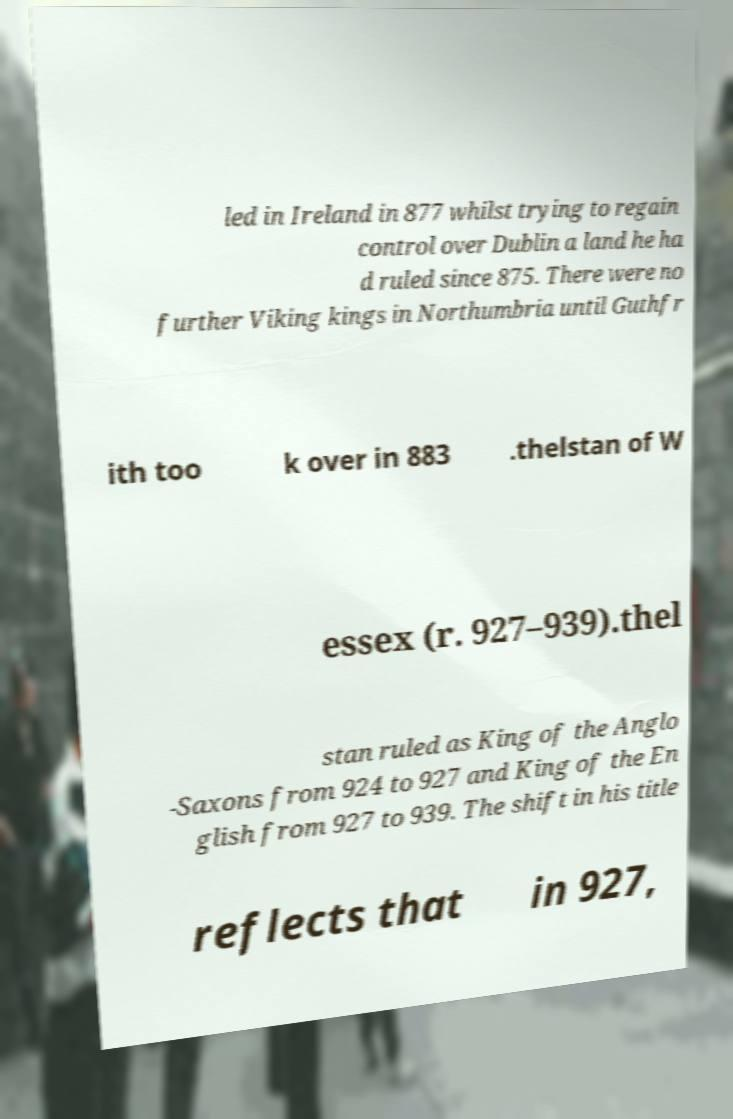Could you extract and type out the text from this image? led in Ireland in 877 whilst trying to regain control over Dublin a land he ha d ruled since 875. There were no further Viking kings in Northumbria until Guthfr ith too k over in 883 .thelstan of W essex (r. 927–939).thel stan ruled as King of the Anglo -Saxons from 924 to 927 and King of the En glish from 927 to 939. The shift in his title reflects that in 927, 